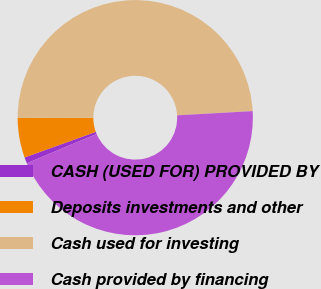Convert chart. <chart><loc_0><loc_0><loc_500><loc_500><pie_chart><fcel>CASH (USED FOR) PROVIDED BY<fcel>Deposits investments and other<fcel>Cash used for investing<fcel>Cash provided by financing<nl><fcel>0.85%<fcel>5.45%<fcel>49.15%<fcel>44.55%<nl></chart> 